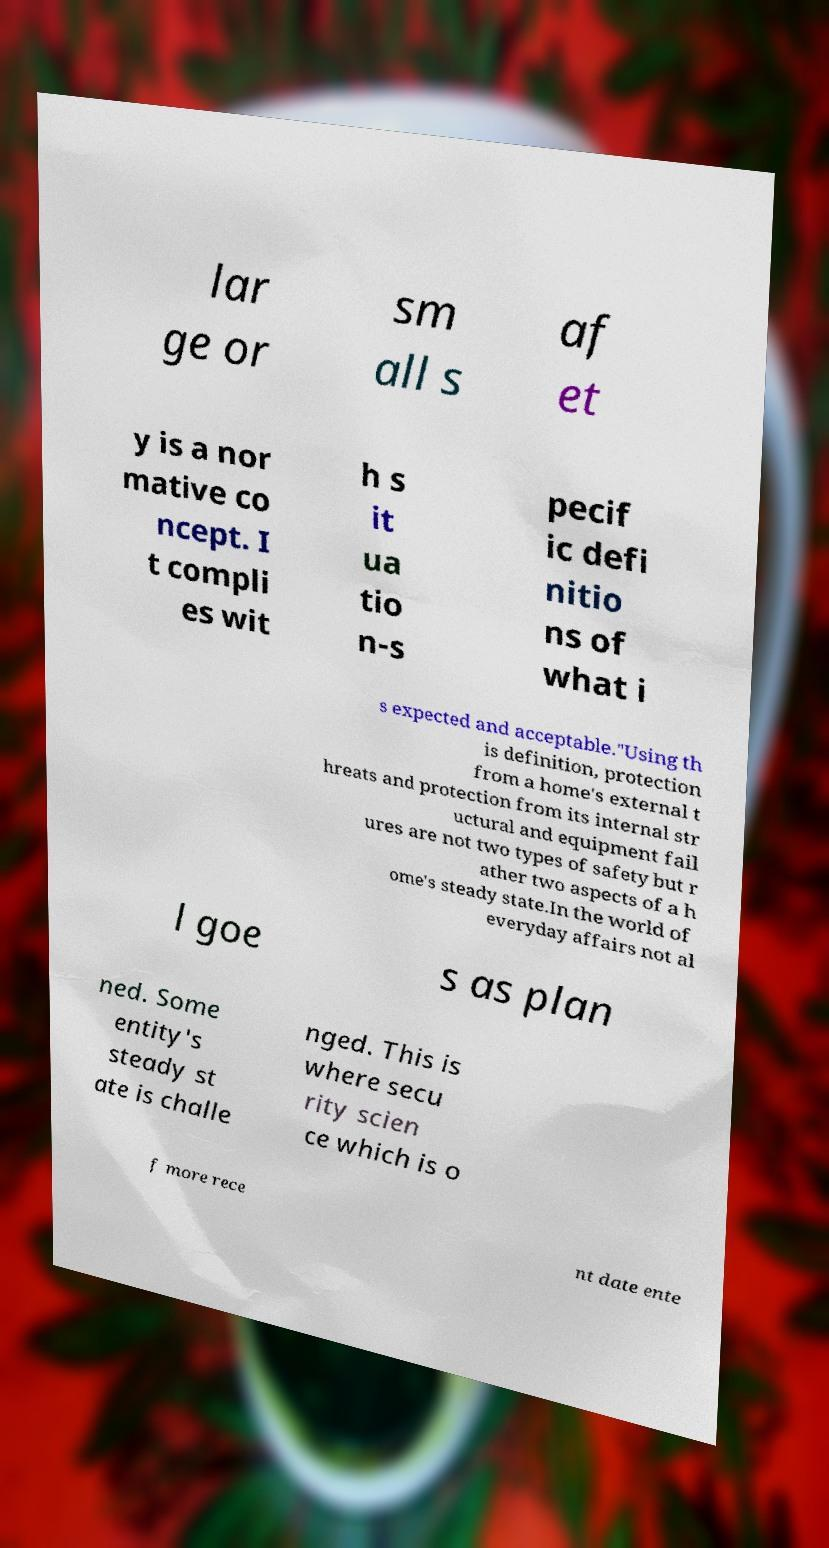What messages or text are displayed in this image? I need them in a readable, typed format. lar ge or sm all s af et y is a nor mative co ncept. I t compli es wit h s it ua tio n-s pecif ic defi nitio ns of what i s expected and acceptable."Using th is definition, protection from a home's external t hreats and protection from its internal str uctural and equipment fail ures are not two types of safety but r ather two aspects of a h ome's steady state.In the world of everyday affairs not al l goe s as plan ned. Some entity's steady st ate is challe nged. This is where secu rity scien ce which is o f more rece nt date ente 